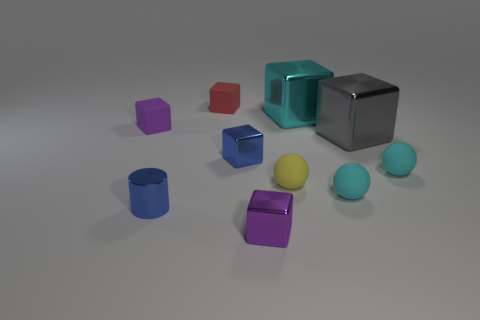There is a tiny blue object that is the same shape as the tiny purple rubber thing; what is its material?
Offer a terse response. Metal. What is the size of the purple block to the right of the red matte thing left of the tiny cyan rubber object to the left of the gray thing?
Ensure brevity in your answer.  Small. Do the purple matte object and the red rubber object have the same size?
Offer a terse response. Yes. The cyan thing that is behind the purple thing that is behind the small purple metallic thing is made of what material?
Provide a succinct answer. Metal. Does the shiny thing in front of the cylinder have the same shape as the metal thing to the right of the cyan shiny cube?
Provide a succinct answer. Yes. Are there an equal number of tiny matte objects that are right of the yellow rubber object and small cyan things?
Offer a terse response. Yes. Are there any large cyan objects that are in front of the tiny rubber block to the left of the tiny red rubber cube?
Ensure brevity in your answer.  No. Are there any other things of the same color as the metal cylinder?
Offer a terse response. Yes. Is the material of the tiny purple thing in front of the small blue metallic cube the same as the blue cylinder?
Your response must be concise. Yes. Is the number of small yellow things that are on the right side of the small shiny cylinder the same as the number of tiny blue metallic cylinders on the right side of the gray object?
Make the answer very short. No. 